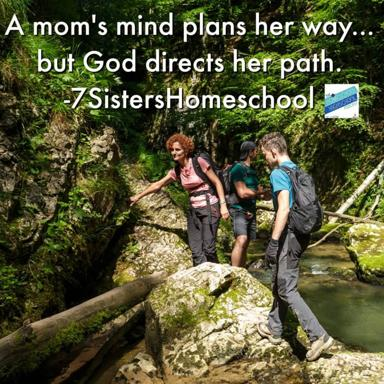Can you explain the activity that the people in the image are engaged in? The group in the image appears to be carefully crossing a stream over a fallen log, likely as part of a hiking or trekking adventure. This activity requires balance and caution, reflecting a theme of navigating life's challenges, similar to the philosophical message present in the text overlay. 